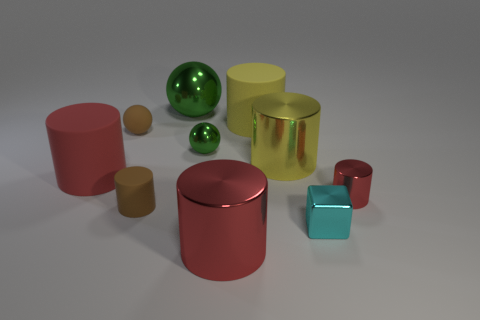There is a red metal object in front of the block; is its size the same as the yellow matte object?
Offer a very short reply. Yes. There is a brown sphere that is the same size as the cyan block; what is its material?
Offer a terse response. Rubber. There is a brown rubber object behind the large yellow metal object to the right of the rubber sphere; is there a large green sphere that is on the left side of it?
Offer a terse response. No. Are there any other things that have the same shape as the small red metal thing?
Your answer should be compact. Yes. There is a sphere right of the big green ball; is it the same color as the cube in front of the small green metal thing?
Offer a very short reply. No. Is there a small green metal cylinder?
Provide a succinct answer. No. There is a large sphere that is the same color as the tiny metal ball; what is its material?
Provide a short and direct response. Metal. There is a green metallic thing that is in front of the metal ball behind the green metal ball right of the big green ball; how big is it?
Your answer should be very brief. Small. There is a tiny green object; is it the same shape as the big matte thing on the left side of the small green metallic thing?
Provide a short and direct response. No. Is there a large object that has the same color as the block?
Offer a terse response. No. 